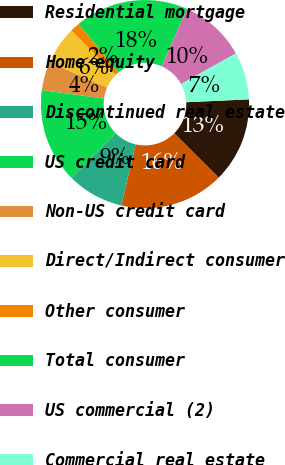<chart> <loc_0><loc_0><loc_500><loc_500><pie_chart><fcel>Residential mortgage<fcel>Home equity<fcel>Discontinued real estate<fcel>US credit card<fcel>Non-US credit card<fcel>Direct/Indirect consumer<fcel>Other consumer<fcel>Total consumer<fcel>US commercial (2)<fcel>Commercial real estate<nl><fcel>13.22%<fcel>16.15%<fcel>8.83%<fcel>14.69%<fcel>4.43%<fcel>5.9%<fcel>1.5%<fcel>17.62%<fcel>10.29%<fcel>7.36%<nl></chart> 